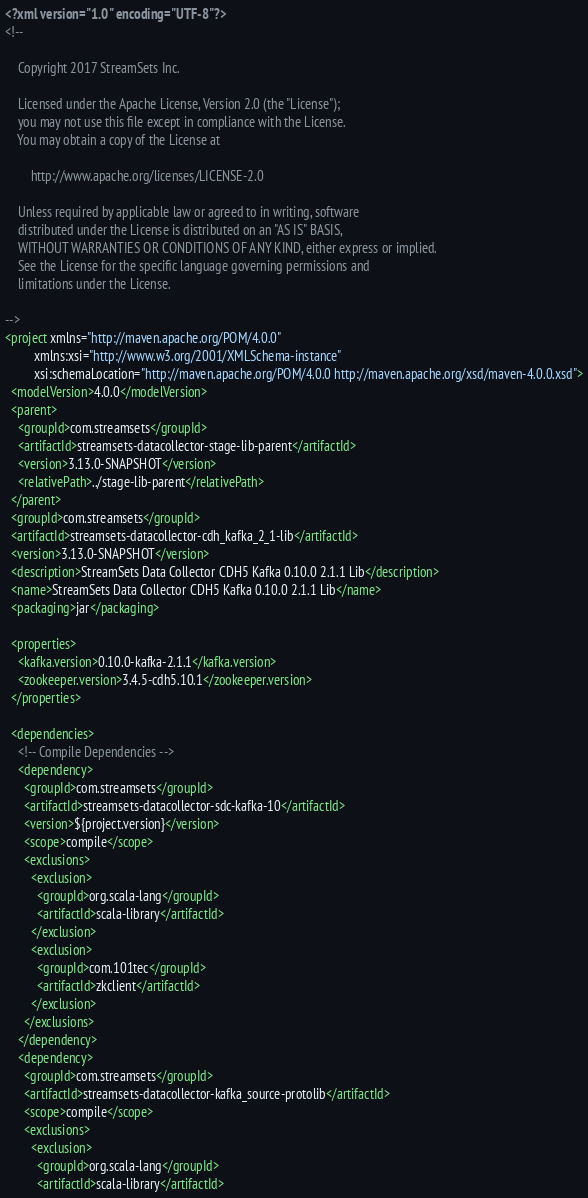<code> <loc_0><loc_0><loc_500><loc_500><_XML_><?xml version="1.0" encoding="UTF-8"?>
<!--

    Copyright 2017 StreamSets Inc.

    Licensed under the Apache License, Version 2.0 (the "License");
    you may not use this file except in compliance with the License.
    You may obtain a copy of the License at

        http://www.apache.org/licenses/LICENSE-2.0

    Unless required by applicable law or agreed to in writing, software
    distributed under the License is distributed on an "AS IS" BASIS,
    WITHOUT WARRANTIES OR CONDITIONS OF ANY KIND, either express or implied.
    See the License for the specific language governing permissions and
    limitations under the License.

-->
<project xmlns="http://maven.apache.org/POM/4.0.0"
         xmlns:xsi="http://www.w3.org/2001/XMLSchema-instance"
         xsi:schemaLocation="http://maven.apache.org/POM/4.0.0 http://maven.apache.org/xsd/maven-4.0.0.xsd">
  <modelVersion>4.0.0</modelVersion>
  <parent>
    <groupId>com.streamsets</groupId>
    <artifactId>streamsets-datacollector-stage-lib-parent</artifactId>
    <version>3.13.0-SNAPSHOT</version>
    <relativePath>../stage-lib-parent</relativePath>
  </parent>
  <groupId>com.streamsets</groupId>
  <artifactId>streamsets-datacollector-cdh_kafka_2_1-lib</artifactId>
  <version>3.13.0-SNAPSHOT</version>
  <description>StreamSets Data Collector CDH5 Kafka 0.10.0 2.1.1 Lib</description>
  <name>StreamSets Data Collector CDH5 Kafka 0.10.0 2.1.1 Lib</name>
  <packaging>jar</packaging>

  <properties>
    <kafka.version>0.10.0-kafka-2.1.1</kafka.version>
    <zookeeper.version>3.4.5-cdh5.10.1</zookeeper.version>
  </properties>

  <dependencies>
    <!-- Compile Dependencies -->
    <dependency>
      <groupId>com.streamsets</groupId>
      <artifactId>streamsets-datacollector-sdc-kafka-10</artifactId>
      <version>${project.version}</version>
      <scope>compile</scope>
      <exclusions>
        <exclusion>
          <groupId>org.scala-lang</groupId>
          <artifactId>scala-library</artifactId>
        </exclusion>
        <exclusion>
          <groupId>com.101tec</groupId>
          <artifactId>zkclient</artifactId>
        </exclusion>
      </exclusions>
    </dependency>
    <dependency>
      <groupId>com.streamsets</groupId>
      <artifactId>streamsets-datacollector-kafka_source-protolib</artifactId>
      <scope>compile</scope>
      <exclusions>
        <exclusion>
          <groupId>org.scala-lang</groupId>
          <artifactId>scala-library</artifactId></code> 